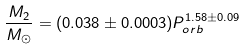<formula> <loc_0><loc_0><loc_500><loc_500>\frac { M _ { 2 } } { M _ { \odot } } = ( 0 . 0 3 8 \pm 0 . 0 0 0 3 ) P _ { o r b } ^ { 1 . 5 8 \pm 0 . 0 9 }</formula> 